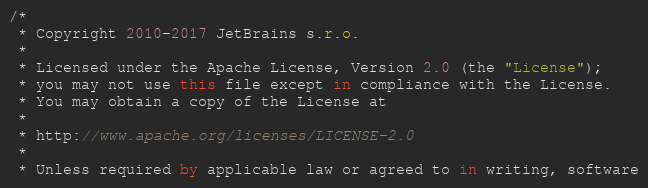Convert code to text. <code><loc_0><loc_0><loc_500><loc_500><_Kotlin_>/*
 * Copyright 2010-2017 JetBrains s.r.o.
 *
 * Licensed under the Apache License, Version 2.0 (the "License");
 * you may not use this file except in compliance with the License.
 * You may obtain a copy of the License at
 *
 * http://www.apache.org/licenses/LICENSE-2.0
 *
 * Unless required by applicable law or agreed to in writing, software</code> 